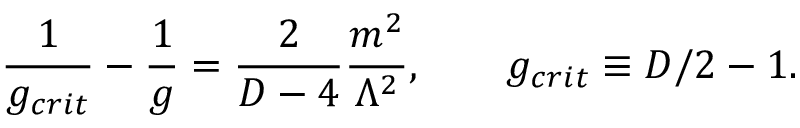Convert formula to latex. <formula><loc_0><loc_0><loc_500><loc_500>\frac { 1 } { g _ { c r i t } } - \frac { 1 } { g } = \frac { 2 } { D - 4 } \frac { m ^ { 2 } } { \Lambda ^ { 2 } } , \quad g _ { c r i t } \equiv D / 2 - 1 .</formula> 